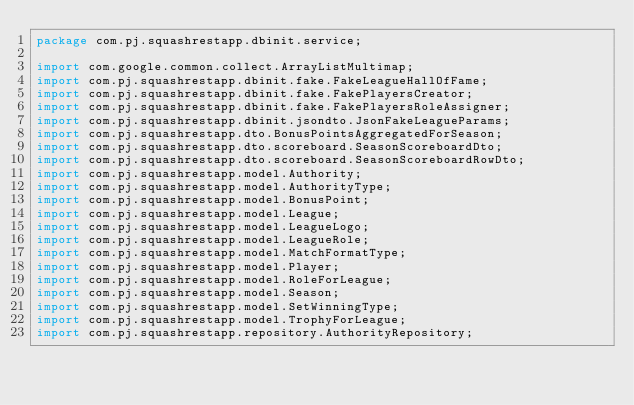<code> <loc_0><loc_0><loc_500><loc_500><_Java_>package com.pj.squashrestapp.dbinit.service;

import com.google.common.collect.ArrayListMultimap;
import com.pj.squashrestapp.dbinit.fake.FakeLeagueHallOfFame;
import com.pj.squashrestapp.dbinit.fake.FakePlayersCreator;
import com.pj.squashrestapp.dbinit.fake.FakePlayersRoleAssigner;
import com.pj.squashrestapp.dbinit.jsondto.JsonFakeLeagueParams;
import com.pj.squashrestapp.dto.BonusPointsAggregatedForSeason;
import com.pj.squashrestapp.dto.scoreboard.SeasonScoreboardDto;
import com.pj.squashrestapp.dto.scoreboard.SeasonScoreboardRowDto;
import com.pj.squashrestapp.model.Authority;
import com.pj.squashrestapp.model.AuthorityType;
import com.pj.squashrestapp.model.BonusPoint;
import com.pj.squashrestapp.model.League;
import com.pj.squashrestapp.model.LeagueLogo;
import com.pj.squashrestapp.model.LeagueRole;
import com.pj.squashrestapp.model.MatchFormatType;
import com.pj.squashrestapp.model.Player;
import com.pj.squashrestapp.model.RoleForLeague;
import com.pj.squashrestapp.model.Season;
import com.pj.squashrestapp.model.SetWinningType;
import com.pj.squashrestapp.model.TrophyForLeague;
import com.pj.squashrestapp.repository.AuthorityRepository;</code> 